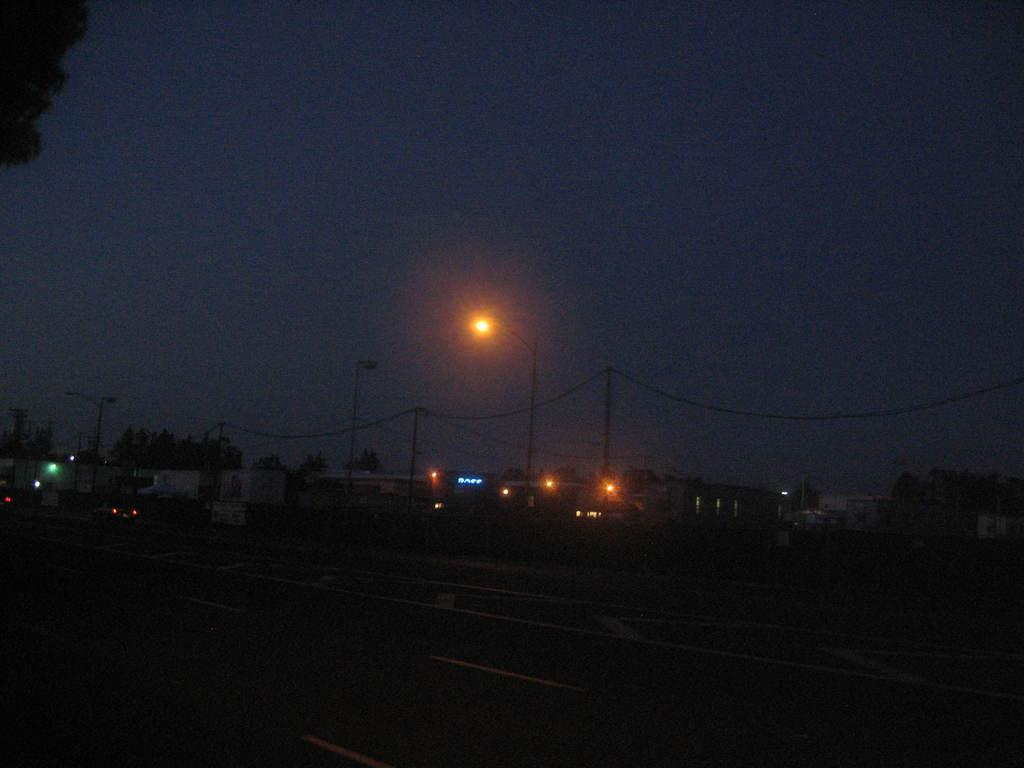What time of day was the image taken? The image was taken at night. What can be seen on the ground in the image? There is a road in the image. What is illuminating the scene in the image? There are lights visible in the image. What structures are present in the image? There are poles in the image. What is visible at the top of the image? The sky is visible at the top of the image. What type of scissors can be seen cutting the grass in the image? There are no scissors or grass present in the image. What day of the week is it in the image? The day of the week is not mentioned or visible in the image. 